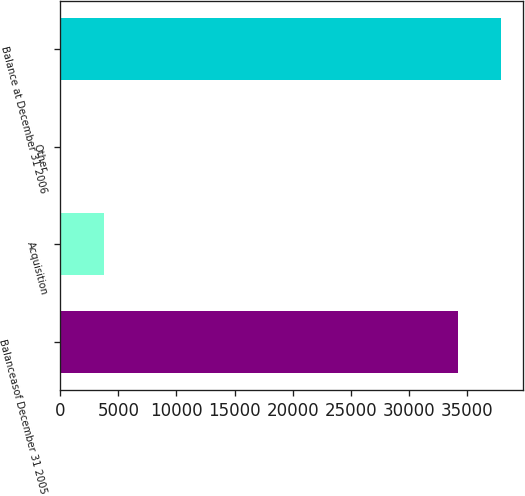Convert chart to OTSL. <chart><loc_0><loc_0><loc_500><loc_500><bar_chart><fcel>Balanceasof December 31 2005<fcel>Acquisition<fcel>Other<fcel>Balance at December 31 2006<nl><fcel>34187<fcel>3779.4<fcel>66<fcel>37900.4<nl></chart> 